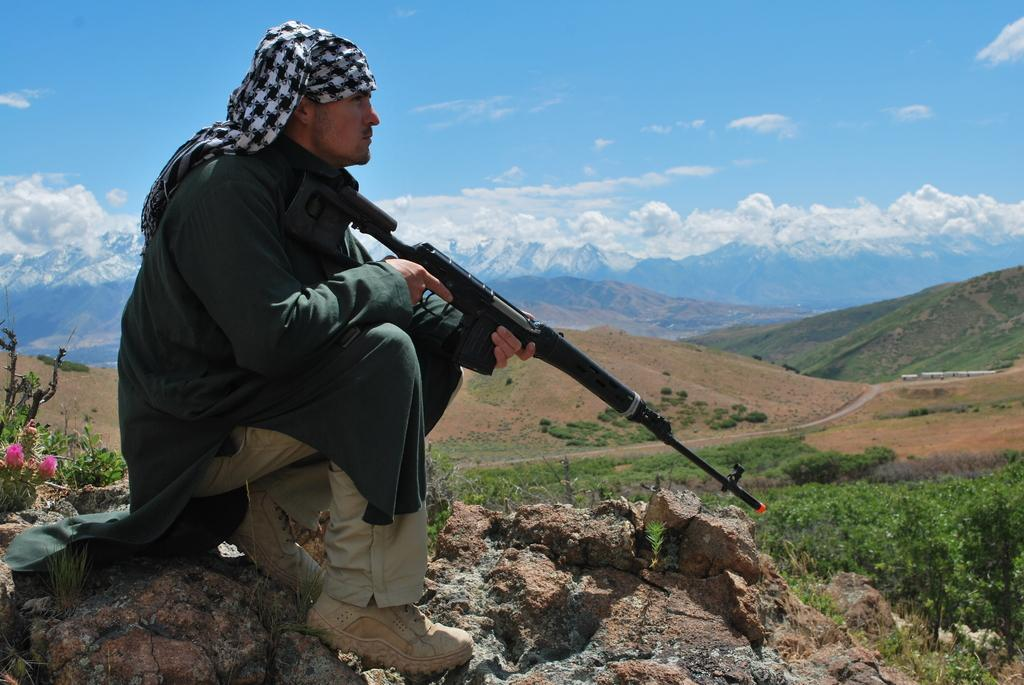What is the main subject of the image? There is a person in the image. What is the person doing in the image? The person is sitting in a squat position on a stone and holding a gun. What type of vegetation can be seen in the image? There are plants and flowers in the image. What is the condition of the sky in the image? The sky is clear in the image. What type of celery is being used to stitch the person's wound in the image? There is no celery or wound present in the image. What type of operation is being performed on the person in the image? There is no operation being performed on the person in the image. 